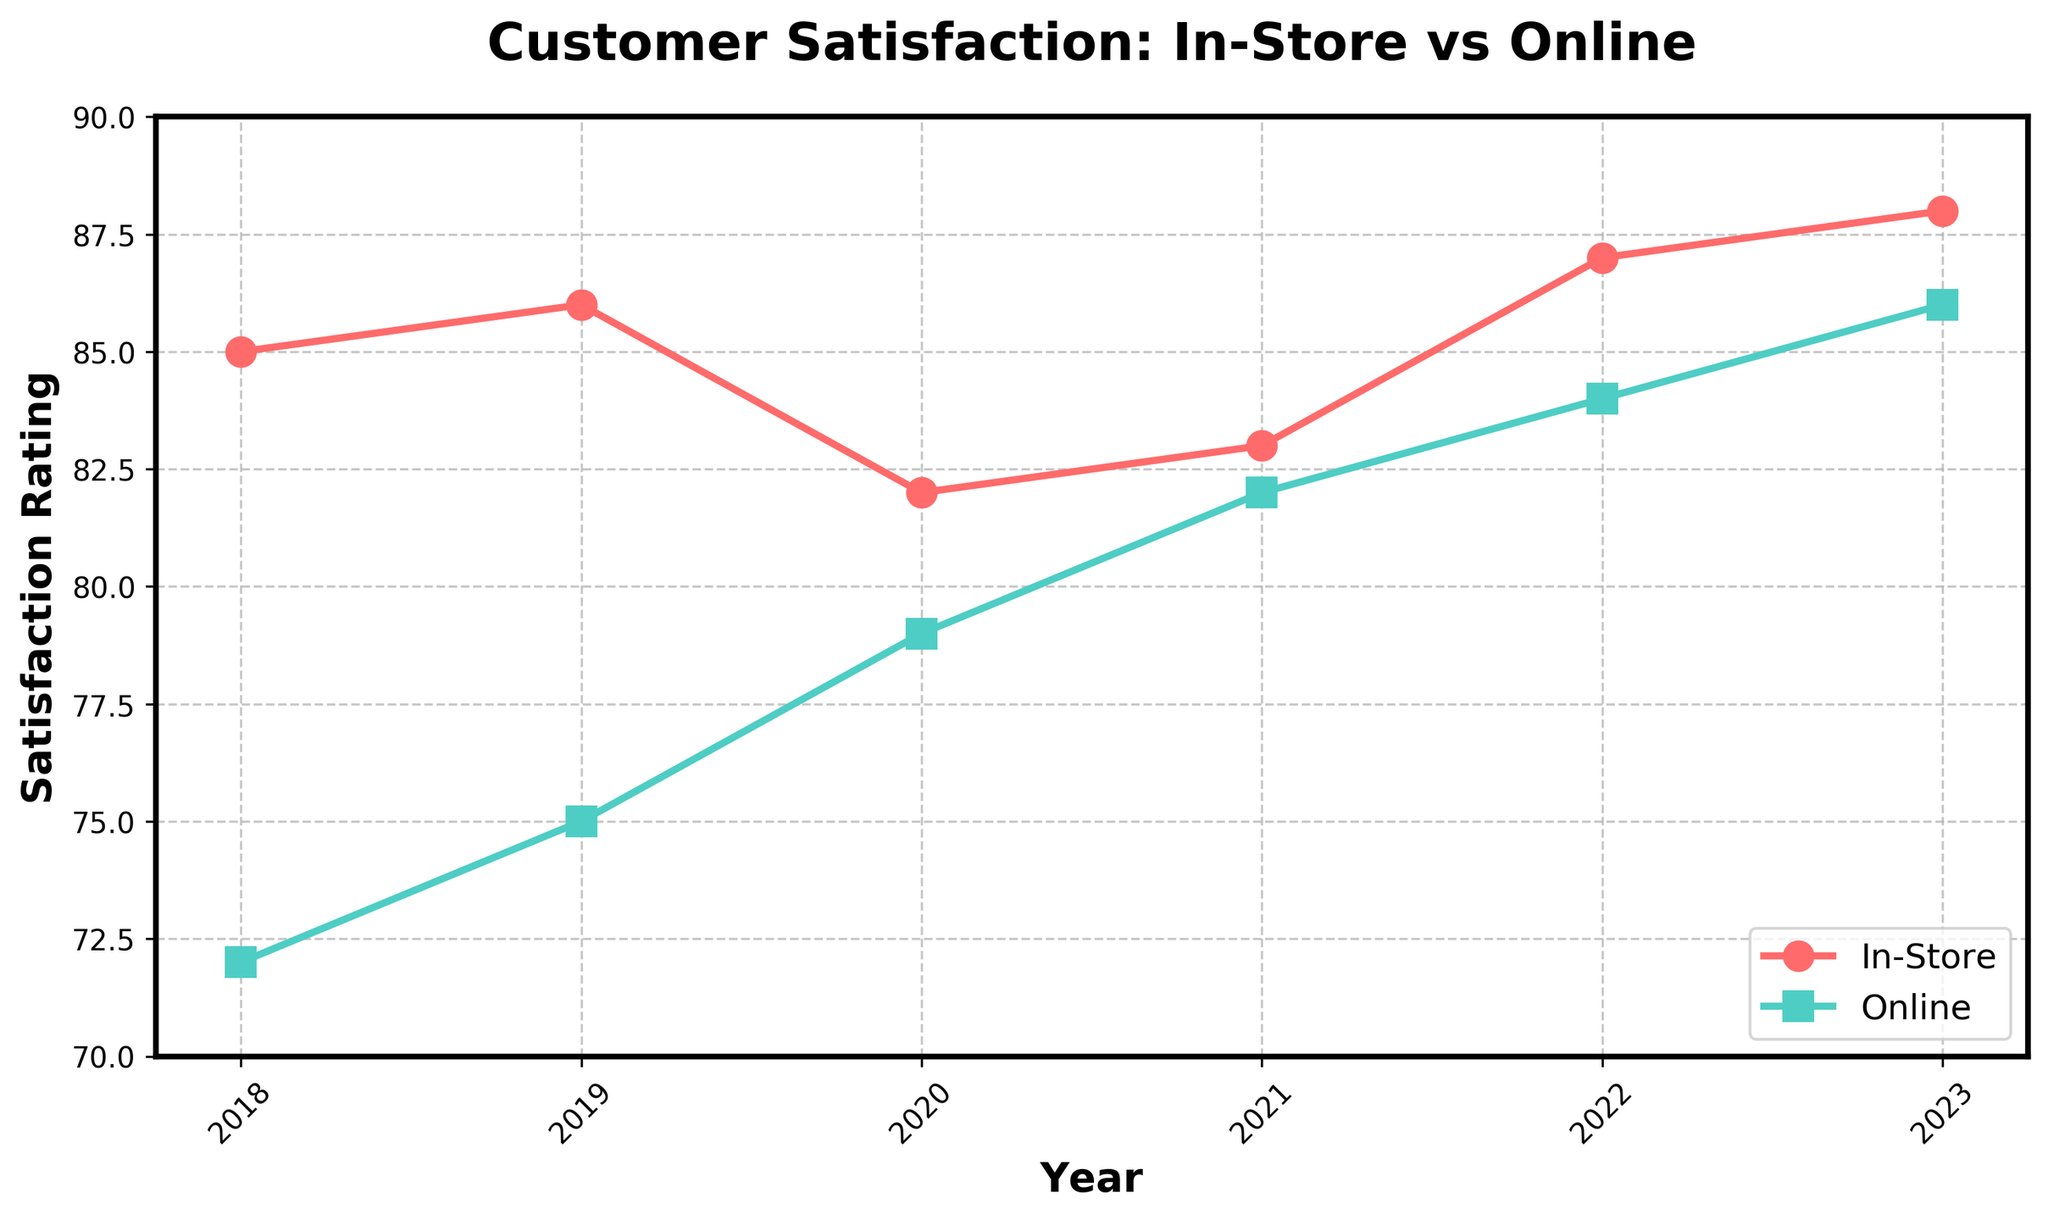What's the average satisfaction rating for in-store service from 2018 to 2023? Sum the in-store satisfaction ratings for each year (85 + 86 + 82 + 83 + 87 + 88) = 511, then divide by the number of years (6). The average is 511/6 ≈ 85.17
Answer: 85.17 Which year had the highest online satisfaction rating? Look at the data points for online satisfaction from 2018 to 2023 and find the highest value. The highest online satisfaction rating is 86 in 2023
Answer: 2023 How does the in-store satisfaction rating in 2023 compare to the online satisfaction rating in 2023? Compare the in-store satisfaction rating (88) and the online satisfaction rating (86) for the year 2023. The in-store satisfaction rating is higher than the online satisfaction rating
Answer: In-store is higher Between 2018 and 2023, which type of satisfaction (in-store or online) showed more improvement? Calculate the difference between the satisfaction ratings from 2018 to 2023 for in-store (88 - 85 = 3) and online (86 - 72 = 14). The improvement for online satisfaction is 14, which is greater than the 3-point improvement for in-store satisfaction
Answer: Online What is the range of satisfaction ratings for in-store service from 2018 to 2023? Find the minimum and maximum in-store satisfaction ratings (min: 82 in 2020, max: 88 in 2023). Calculate the range by subtracting the minimum from the maximum (88 - 82 = 6)
Answer: 6 In which year did the online satisfaction rating surpass the in-store satisfaction rating for the first time? Compare annual ratings year by year until the online satisfaction surpasses the in-store rating. This first happens in 2021 with online satisfaction at 82 and in-store at 83
Answer: 2021 What's the combined satisfaction rating for both in-store and online in 2022? Add the satisfaction ratings for in-store (87) and online (84) in 2022. The combined rating is 87 + 84 = 171
Answer: 171 How did the in-store satisfaction rating change from 2019 to 2020 compared to the online satisfaction rating? Calculate the change for in-store (82 - 86 = -4) and online (79 - 75 = 4). In-store satisfaction decreased by 4 points, while online satisfaction increased by 4 points
Answer: In-store decreased by 4, online increased by 4 Which satisfaction rating had a consistent upward trend from 2018 to 2023? Observe the trend in satisfaction ratings from 2018 to 2023. The online satisfaction consistently increases each year (72, 75, 79, 82, 84, 86) while in-store satisfaction fluctuates
Answer: Online satisfaction What is the difference in the in-store satisfaction rating between 2018 and 2023? Subtract the in-store satisfaction rating of 2018 (85) from that of 2023 (88). The difference is 88 - 85 = 3
Answer: 3 